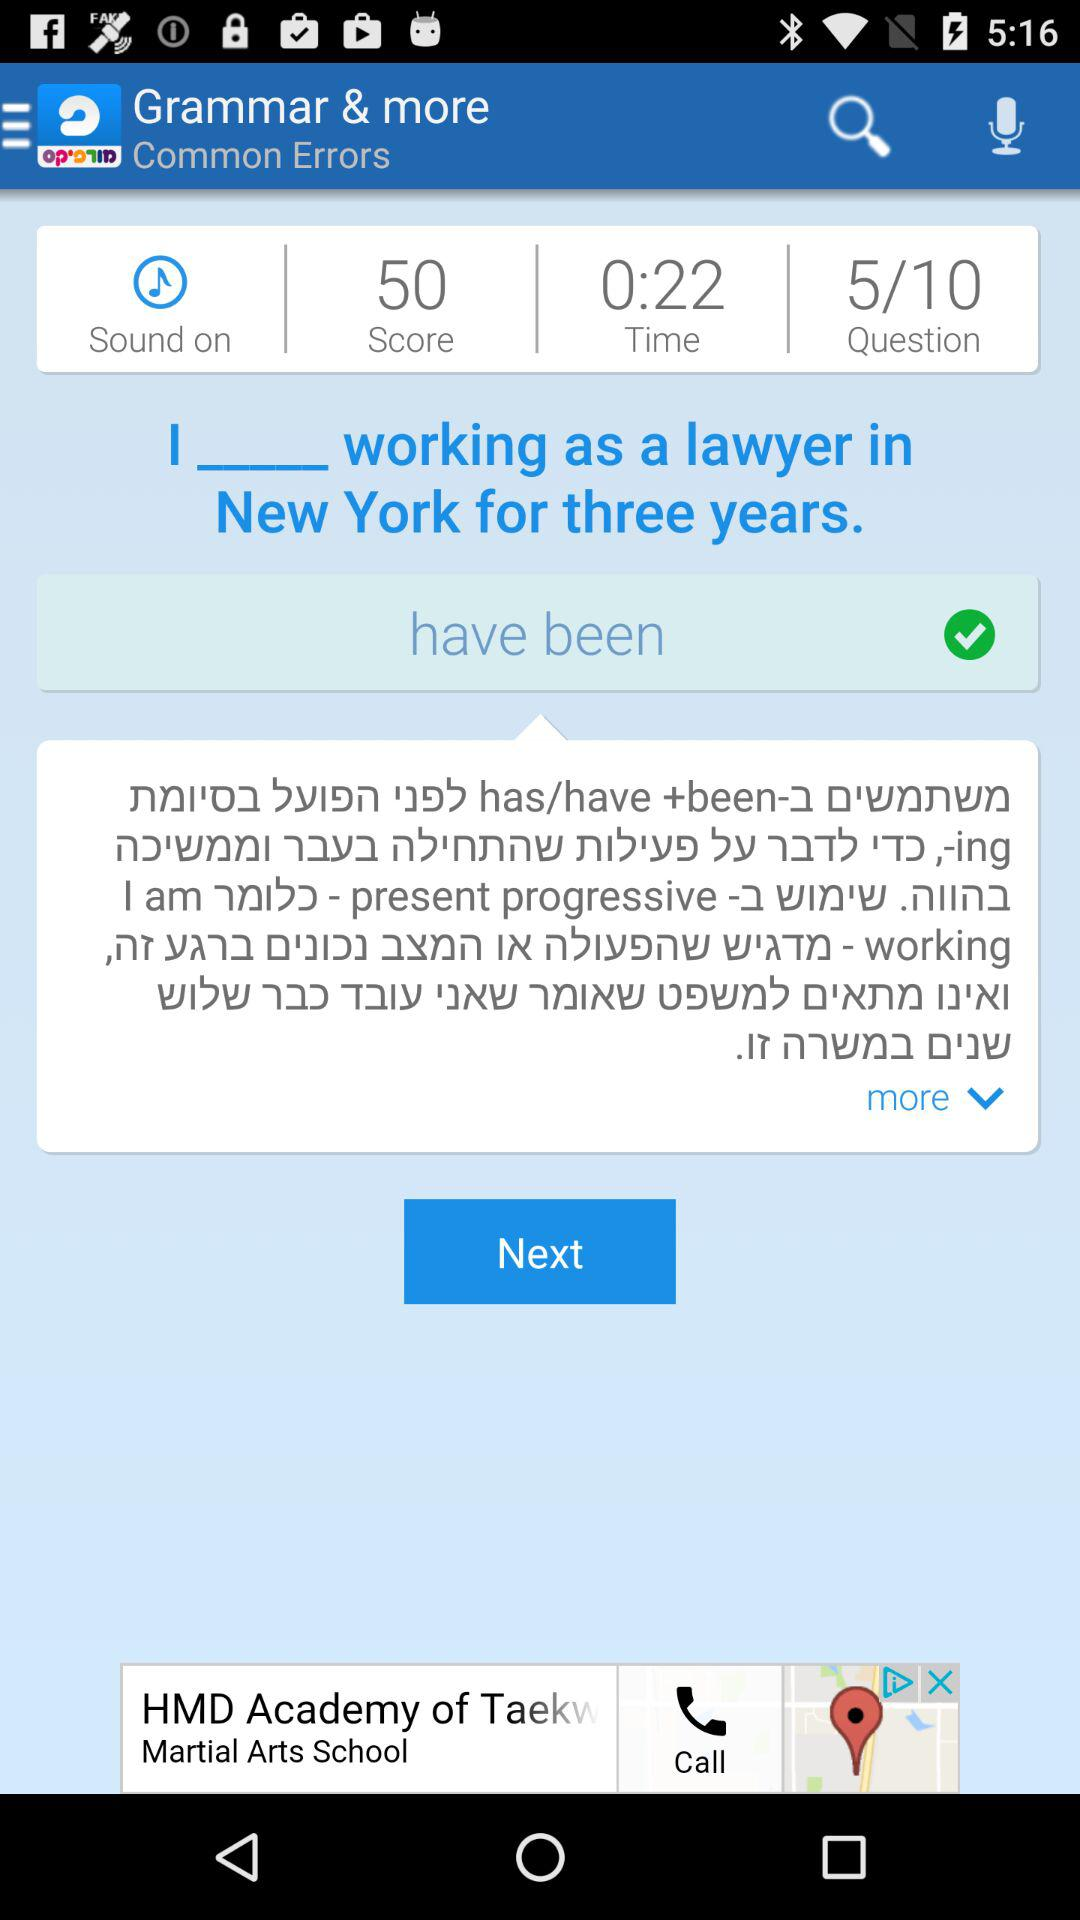What is the remaining time? The remaining time is 22 seconds. 